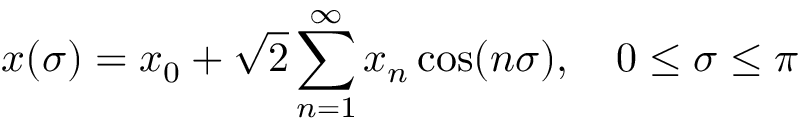Convert formula to latex. <formula><loc_0><loc_0><loc_500><loc_500>x ( \sigma ) = x _ { 0 } + \sqrt { 2 } \sum _ { n = 1 } ^ { \infty } x _ { n } \cos ( n \sigma ) , 0 \leq \sigma \leq \pi</formula> 